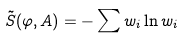<formula> <loc_0><loc_0><loc_500><loc_500>\tilde { S } ( \varphi , A ) = - \sum w _ { i } \ln w _ { i }</formula> 